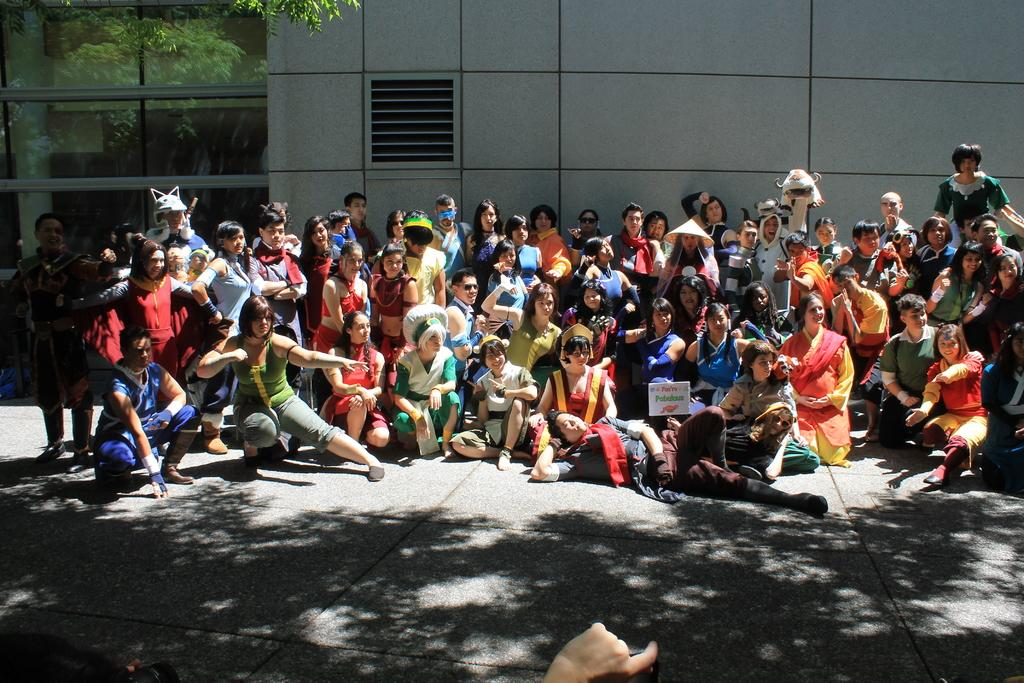What is the general composition of the people in the image? There is a crowd in the image, with some people sitting and some standing. What can be seen in the background of the image? There are trees, mirrors, walls, and a floor visible in the background of the image. How does the crowd compare to the size of the cellar in the image? There is no mention of a cellar in the image, so it cannot be compared to the size of the crowd. 